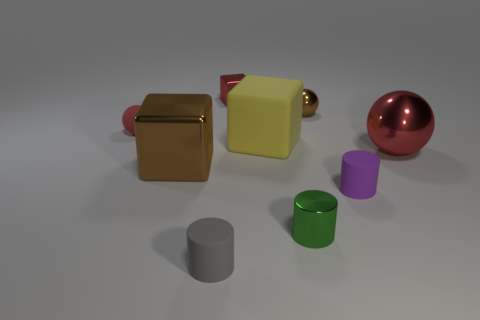Can you tell me the colors of the different objects present in the image? Certainly! In the image, we have a variety of colored objects: a golden cube on the left, a coral-pinkish sphere on the right, a bright green cylinder in the foreground, a purple cylinder behind it, a gray cylinder in the center, and a muted yellow cube in the back. 